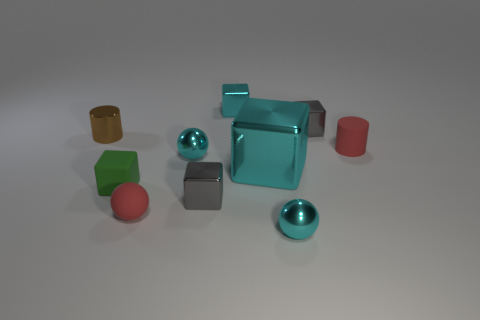Is the number of tiny metallic objects less than the number of small yellow metallic cubes?
Offer a very short reply. No. There is a green matte block; is it the same size as the cyan cube that is on the right side of the tiny cyan cube?
Your answer should be compact. No. How many rubber things are either red things or small cylinders?
Keep it short and to the point. 2. Are there more gray blocks than tiny spheres?
Offer a very short reply. No. What shape is the gray thing that is left of the tiny gray metallic cube that is behind the metallic cylinder?
Your answer should be compact. Cube. There is a small red object behind the gray cube that is in front of the green thing; are there any tiny metallic objects that are behind it?
Your response must be concise. Yes. The matte cylinder that is the same size as the green cube is what color?
Ensure brevity in your answer.  Red. There is a object that is on the left side of the red rubber ball and to the right of the brown metal cylinder; what is its shape?
Offer a very short reply. Cube. What size is the green matte block behind the small cyan object that is in front of the tiny green rubber block?
Make the answer very short. Small. How many shiny cubes have the same color as the big shiny object?
Keep it short and to the point. 1. 